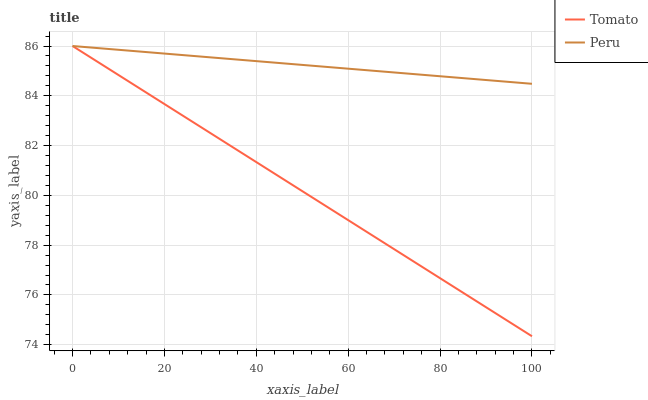Does Tomato have the minimum area under the curve?
Answer yes or no. Yes. Does Peru have the maximum area under the curve?
Answer yes or no. Yes. Does Peru have the minimum area under the curve?
Answer yes or no. No. Is Peru the smoothest?
Answer yes or no. Yes. Is Tomato the roughest?
Answer yes or no. Yes. Is Peru the roughest?
Answer yes or no. No. Does Tomato have the lowest value?
Answer yes or no. Yes. Does Peru have the lowest value?
Answer yes or no. No. Does Peru have the highest value?
Answer yes or no. Yes. Does Peru intersect Tomato?
Answer yes or no. Yes. Is Peru less than Tomato?
Answer yes or no. No. Is Peru greater than Tomato?
Answer yes or no. No. 